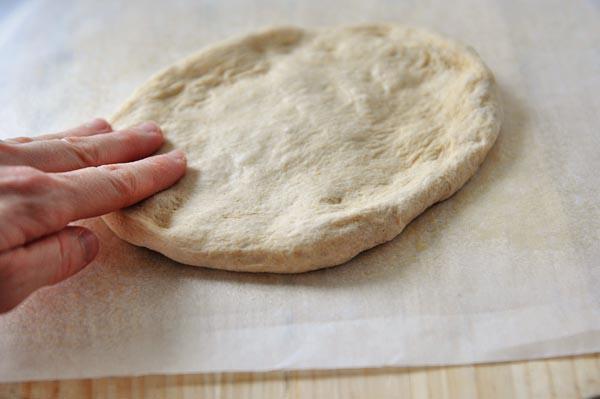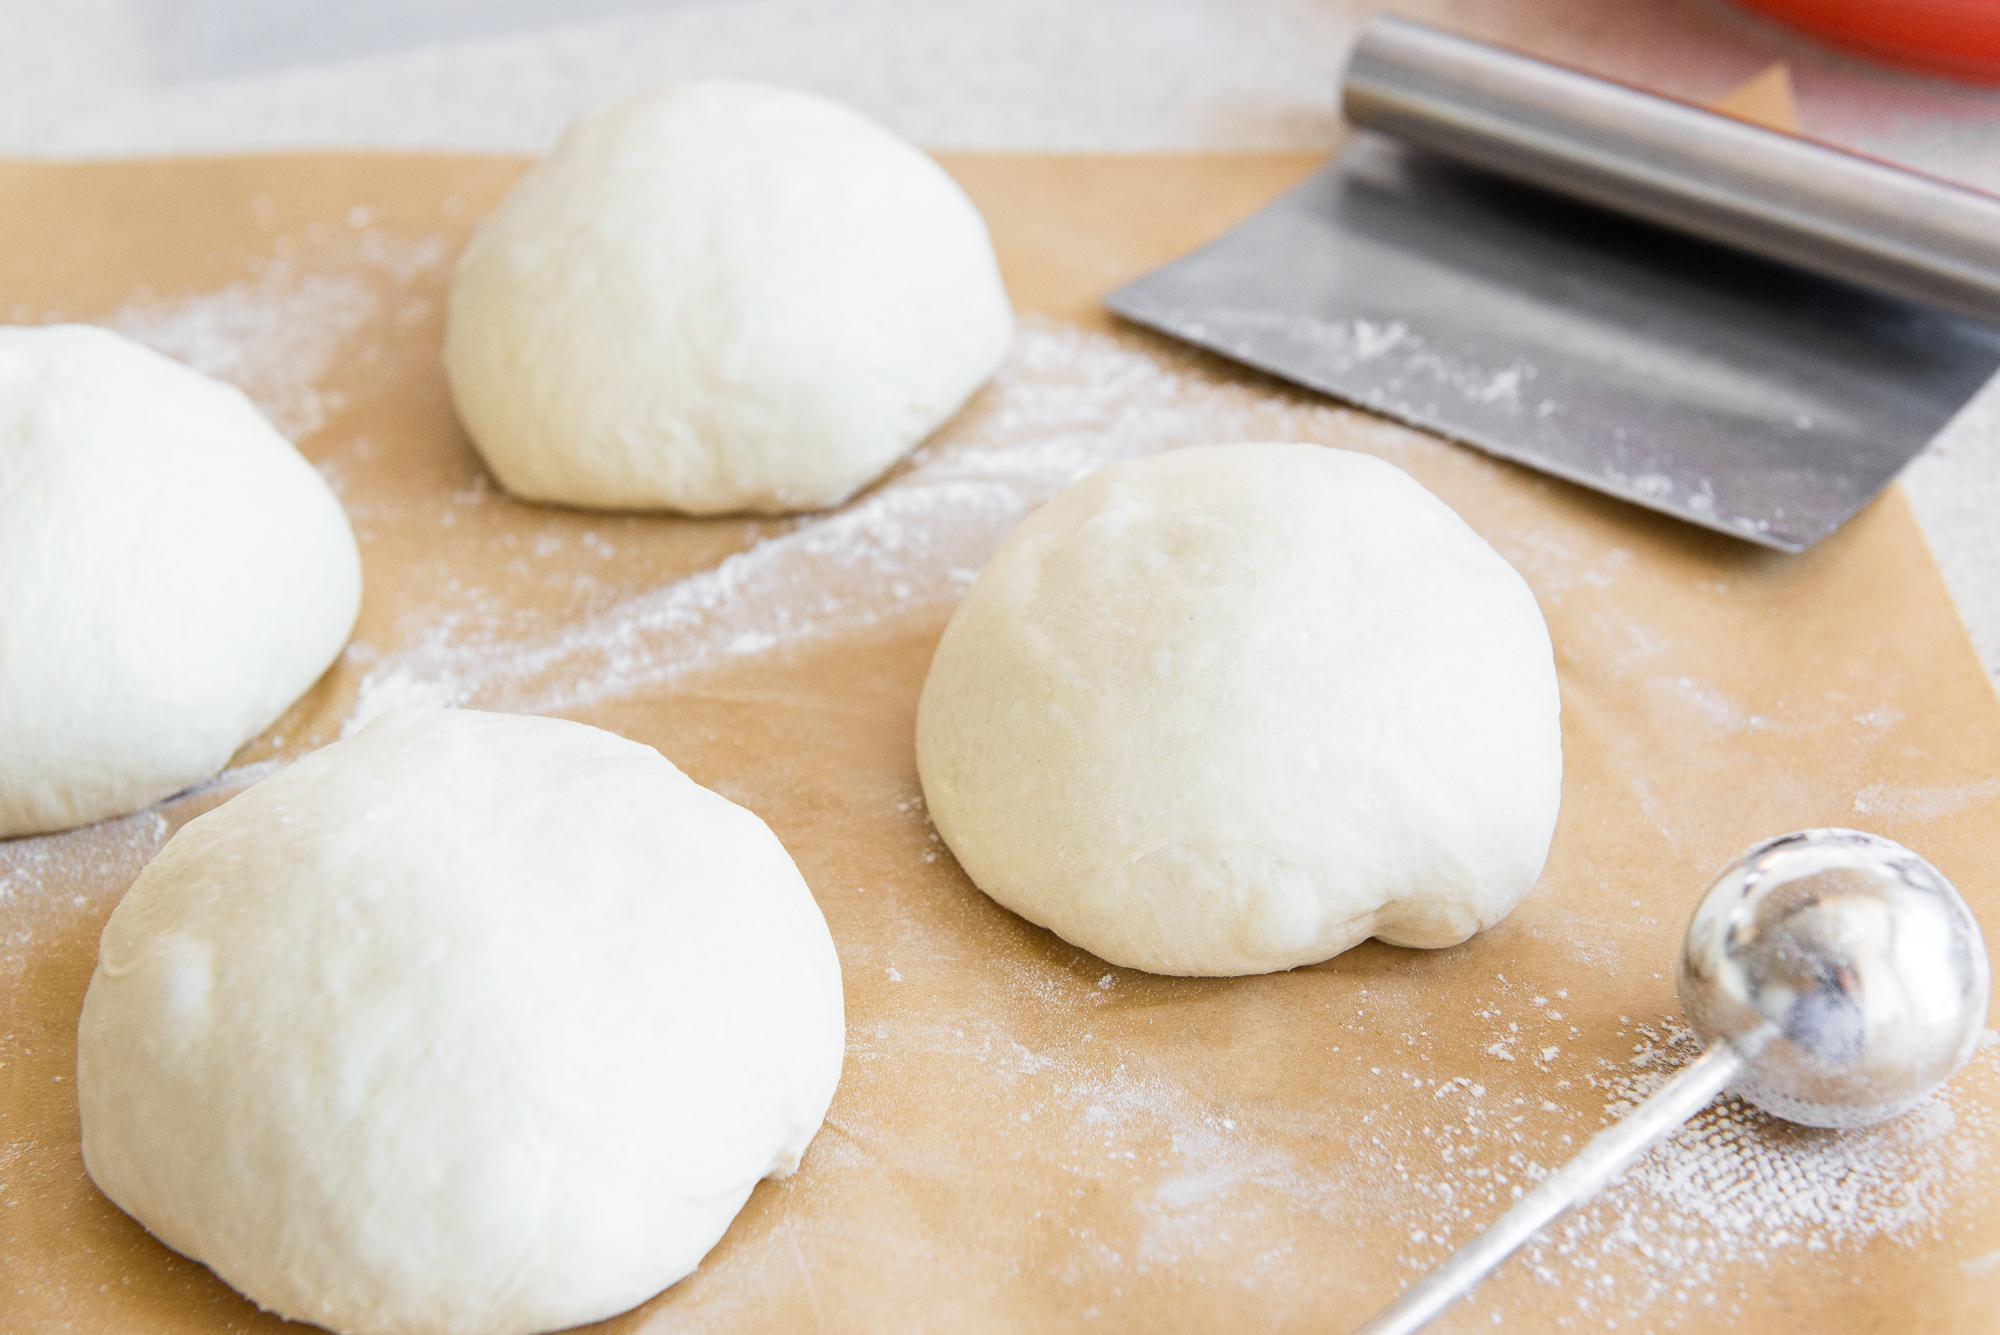The first image is the image on the left, the second image is the image on the right. Considering the images on both sides, is "One piece of dough is flattened." valid? Answer yes or no. Yes. The first image is the image on the left, the second image is the image on the right. Considering the images on both sides, is "The right image shows at least three round mounds of dough on floured brown paper." valid? Answer yes or no. Yes. 